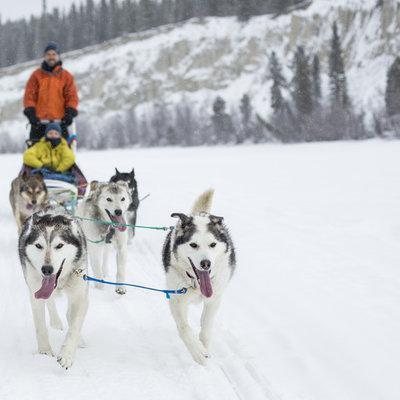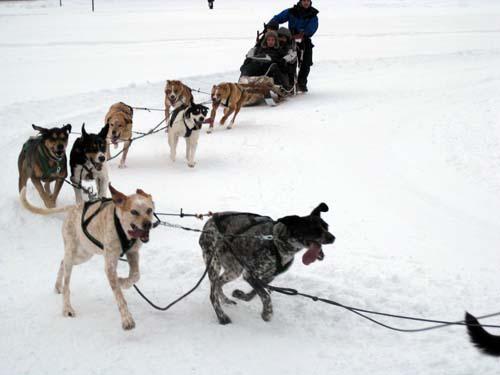The first image is the image on the left, the second image is the image on the right. Evaluate the accuracy of this statement regarding the images: "There are people in both images.". Is it true? Answer yes or no. Yes. The first image is the image on the left, the second image is the image on the right. Assess this claim about the two images: "The dog team in the left image is headed forward in a straight path, while the dog team in the right image has veered to the right.". Correct or not? Answer yes or no. Yes. 